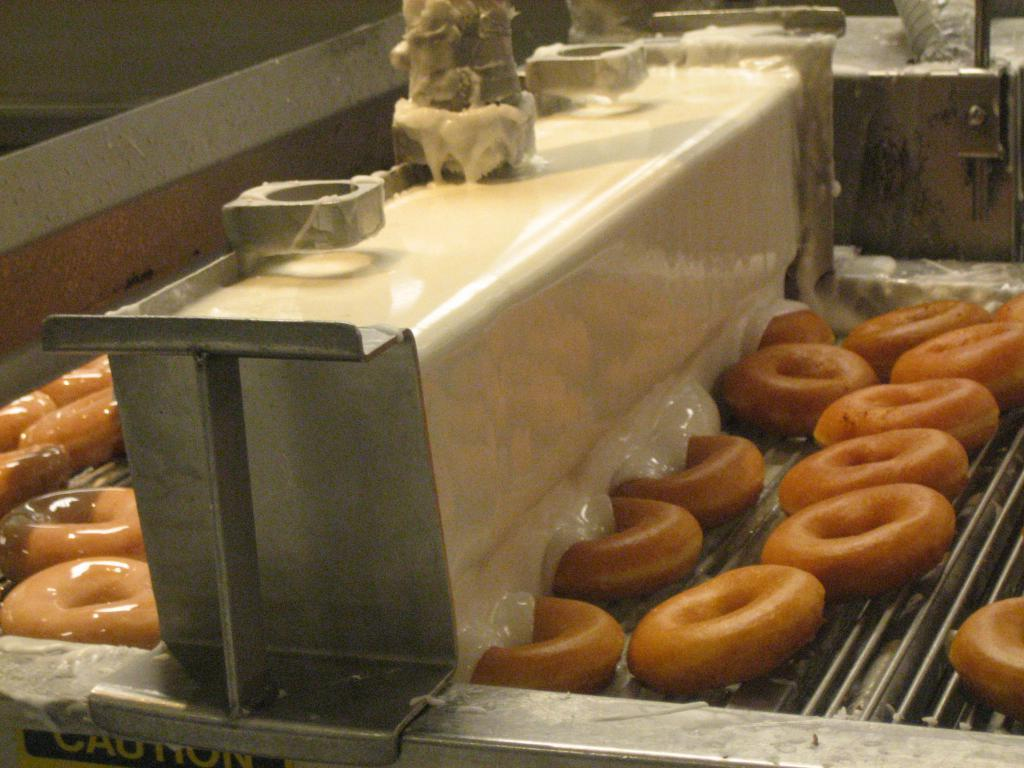What type of food is visible in the image? There is a group of donuts in the image. How are the donuts arranged in the image? The donuts are placed on a conveyor. What can be seen in the background of the image? There are metal sheets in the background of the image. What type of shock can be seen affecting the group of donuts in the image? There is no shock affecting the group of donuts in the image; they are simply placed on a conveyor. 